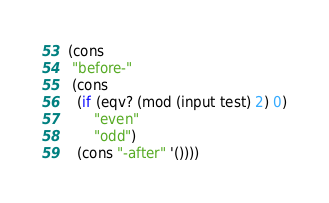Convert code to text. <code><loc_0><loc_0><loc_500><loc_500><_Scheme_>(cons
 "before-"
 (cons
  (if (eqv? (mod (input test) 2) 0)
      "even"
      "odd")
  (cons "-after" '())))
</code> 